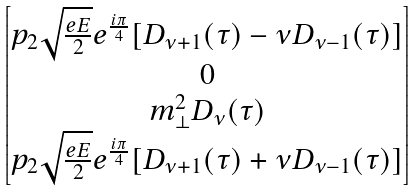<formula> <loc_0><loc_0><loc_500><loc_500>\begin{bmatrix} p _ { 2 } \sqrt { \frac { e E } 2 } e ^ { \frac { i \pi } 4 } [ D _ { \nu + 1 } ( \tau ) - \nu D _ { \nu - 1 } ( \tau ) ] \\ 0 \\ m _ { \perp } ^ { 2 } D _ { \nu } ( \tau ) \\ p _ { 2 } \sqrt { \frac { e E } 2 } e ^ { \frac { i \pi } 4 } [ D _ { \nu + 1 } ( \tau ) + \nu D _ { \nu - 1 } ( \tau ) ] \end{bmatrix}</formula> 